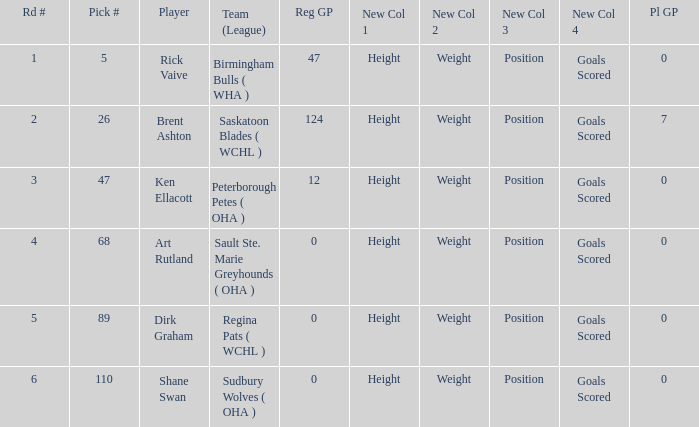How many rounds exist for picks under 5? 0.0. 